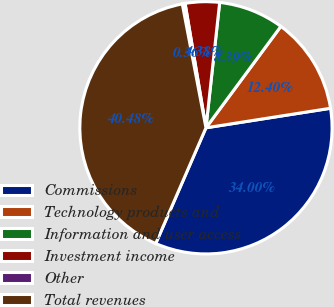Convert chart to OTSL. <chart><loc_0><loc_0><loc_500><loc_500><pie_chart><fcel>Commissions<fcel>Technology products and<fcel>Information and user access<fcel>Investment income<fcel>Other<fcel>Total revenues<nl><fcel>34.0%<fcel>12.4%<fcel>8.39%<fcel>4.38%<fcel>0.36%<fcel>40.48%<nl></chart> 